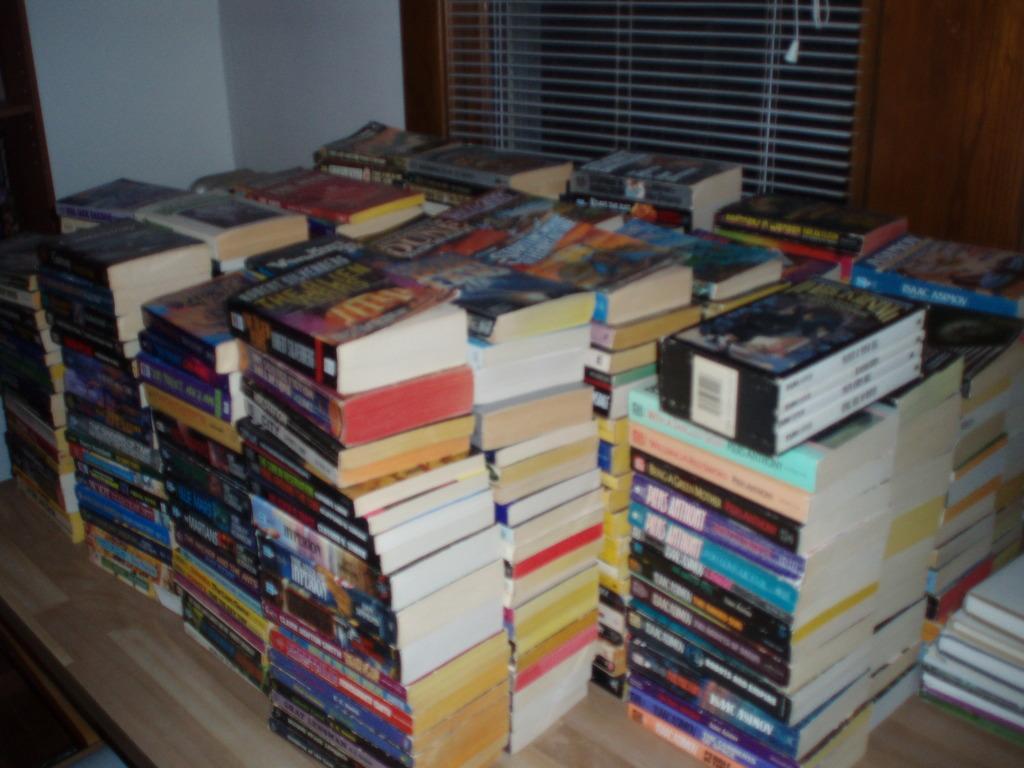Please provide a concise description of this image. In the center of the image we can see a platform. On the platform, we can see a different types of books. In the background, there is a wall and window blind. 